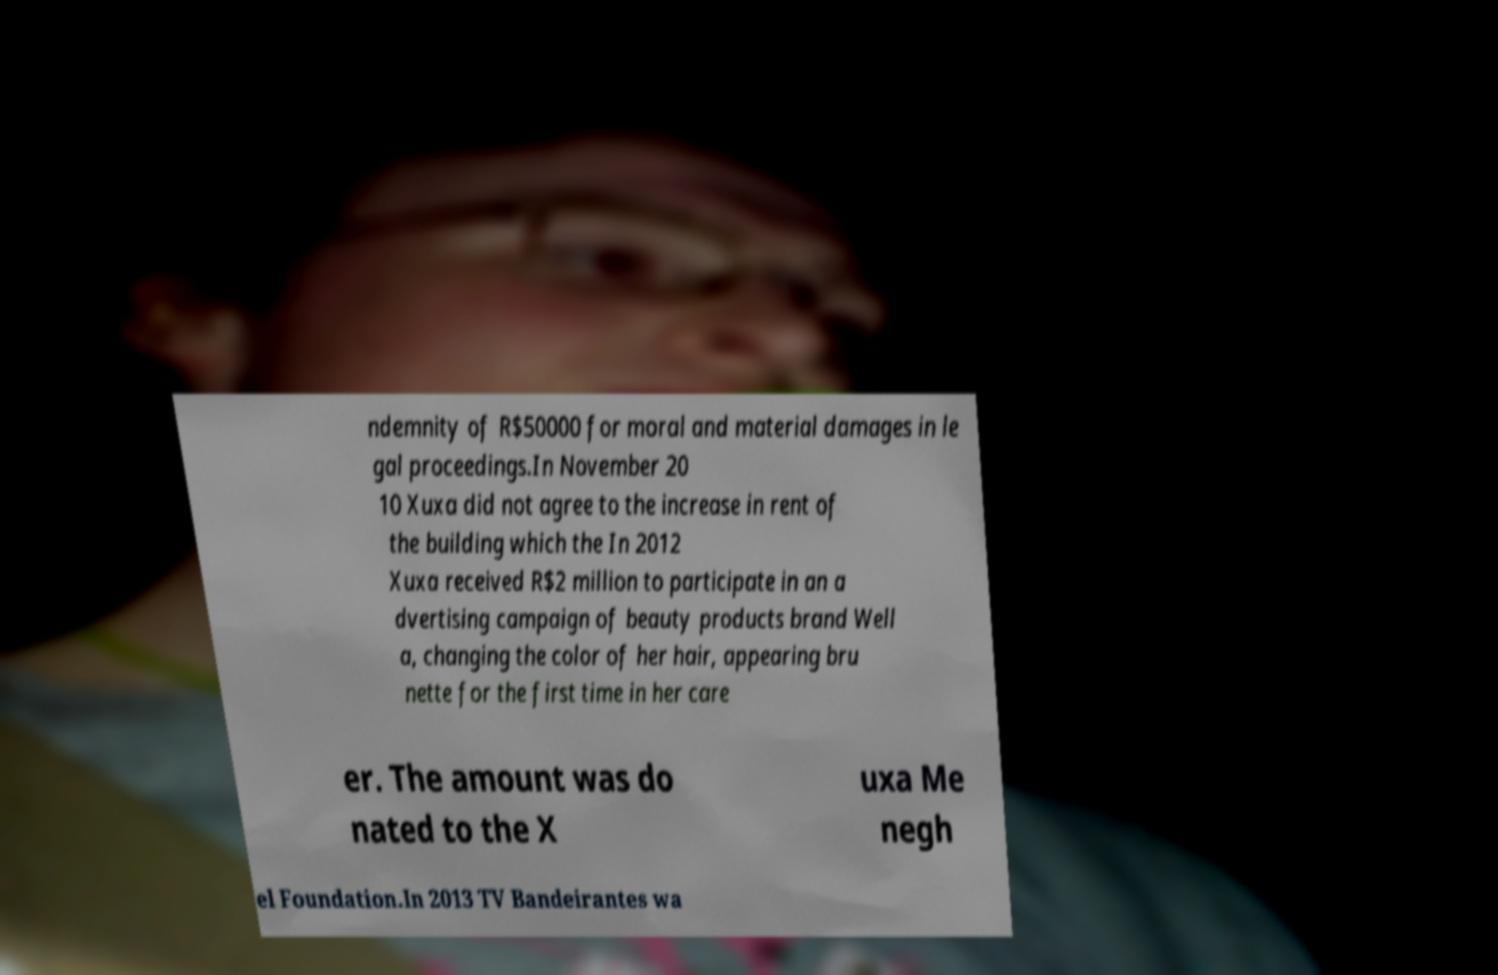Could you assist in decoding the text presented in this image and type it out clearly? ndemnity of R$50000 for moral and material damages in le gal proceedings.In November 20 10 Xuxa did not agree to the increase in rent of the building which the In 2012 Xuxa received R$2 million to participate in an a dvertising campaign of beauty products brand Well a, changing the color of her hair, appearing bru nette for the first time in her care er. The amount was do nated to the X uxa Me negh el Foundation.In 2013 TV Bandeirantes wa 